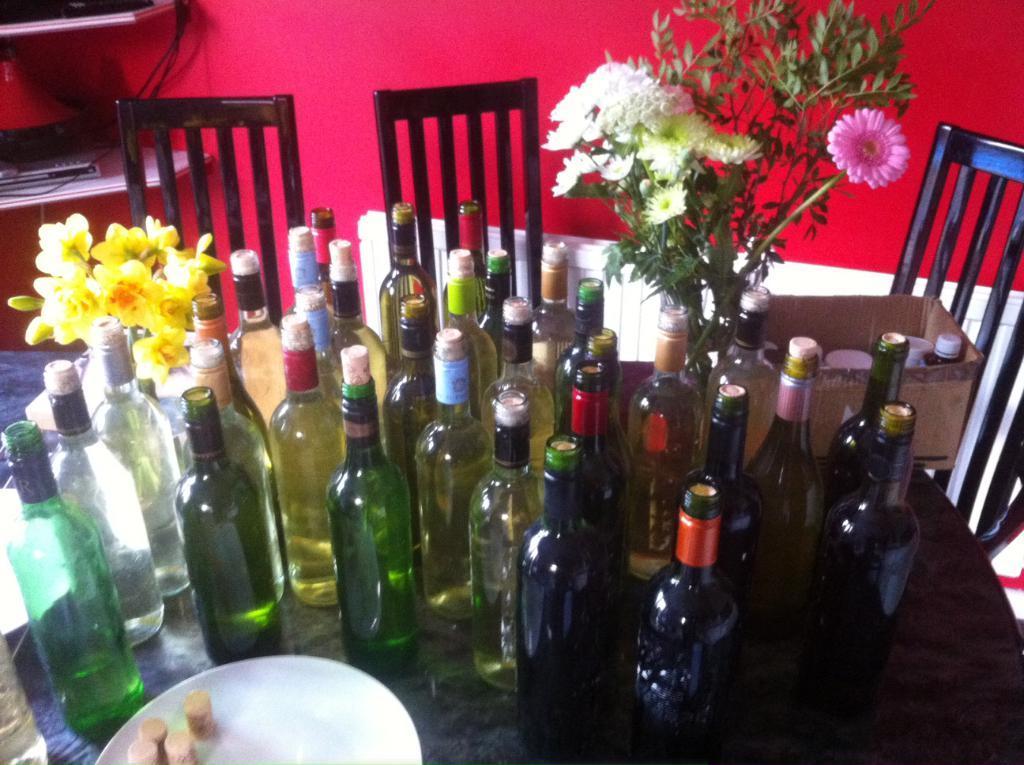Could you give a brief overview of what you see in this image? This picture shows a bunch of wine bottles and a plant and flowers with a plate on the table and we see three chairs 